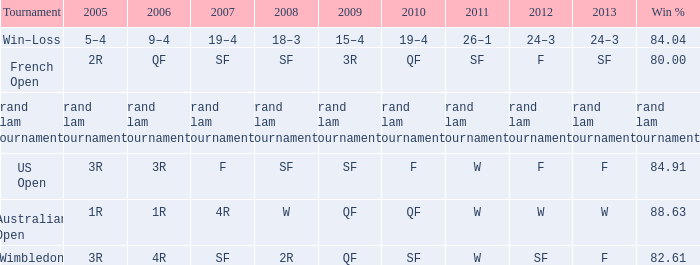WHat in 2005 has a Win % of 82.61? 3R. 